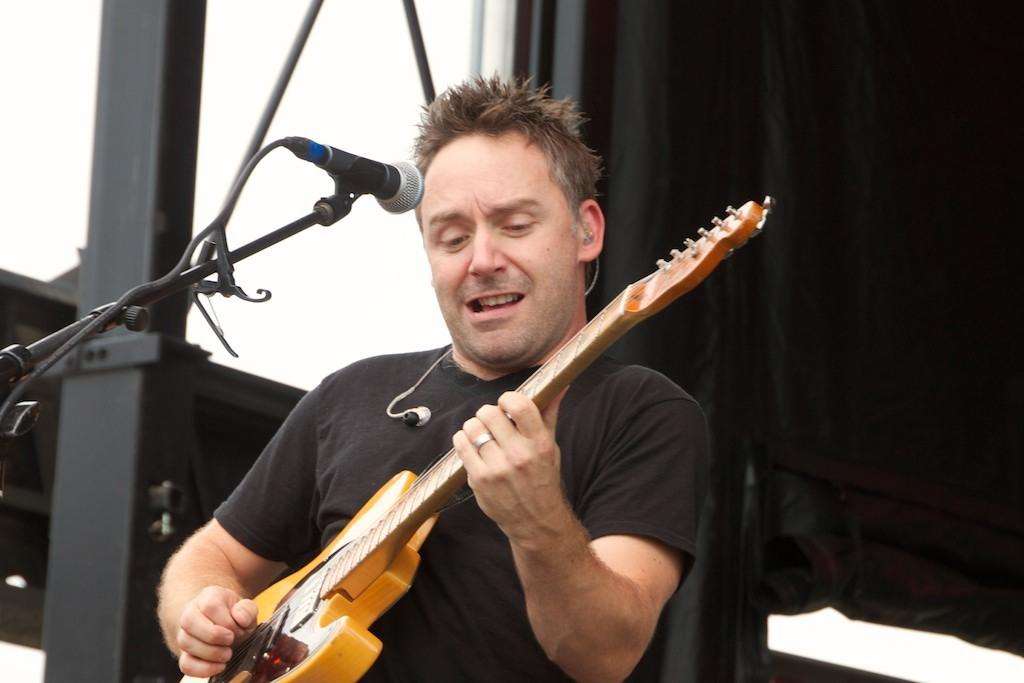Where is the setting of the image? The image is outside of a room. Who is present in the image? There is a man in the image. What is the man holding in the image? The man is holding a guitar. What is the man doing with the guitar? The man is playing the guitar. What is the man standing in front of? The man is in front of a microphone. What color is the curtain in the background of the image? There is a black color curtain in the background of the image. What type of sponge is the man using to play the guitar in the image? There is no sponge present in the image, and the man is playing the guitar with his hands. 